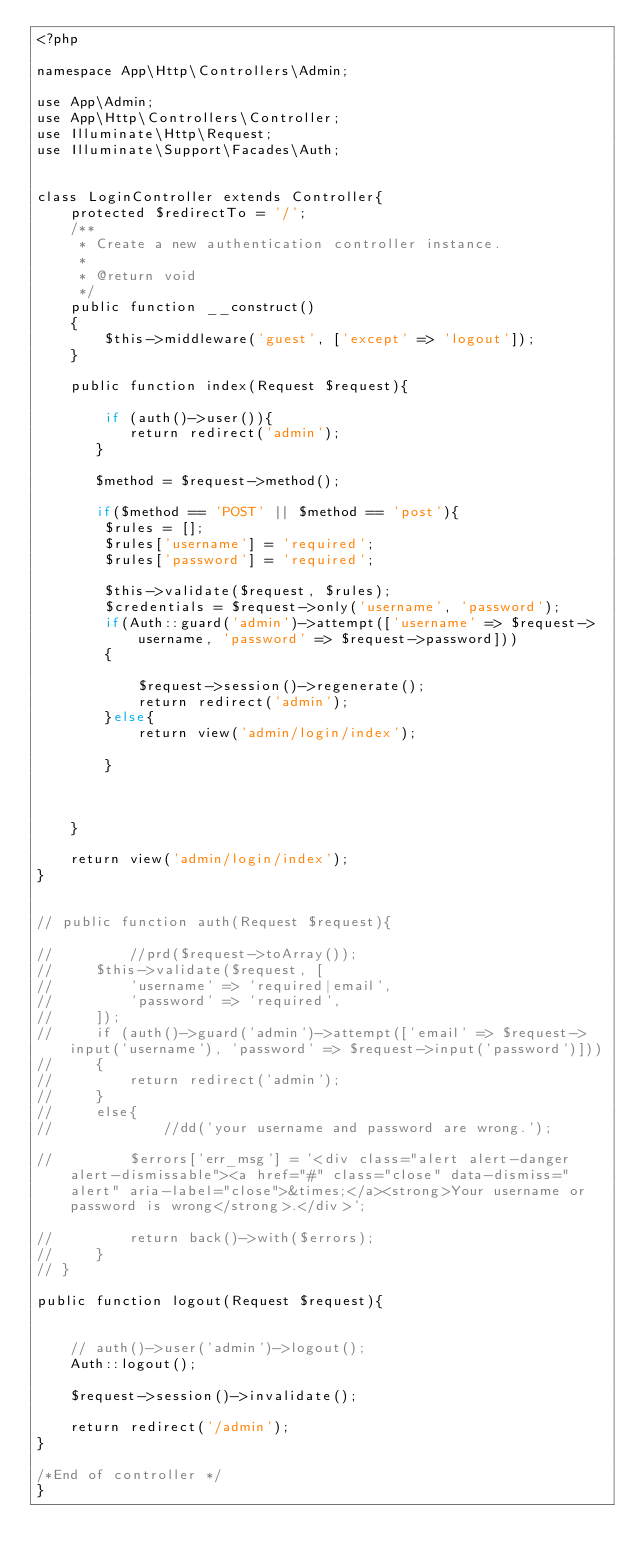Convert code to text. <code><loc_0><loc_0><loc_500><loc_500><_PHP_><?php

namespace App\Http\Controllers\Admin;

use App\Admin;
use App\Http\Controllers\Controller;
use Illuminate\Http\Request;
use Illuminate\Support\Facades\Auth;


class LoginController extends Controller{
    protected $redirectTo = '/';
    /**
     * Create a new authentication controller instance.
     *
     * @return void
     */
    public function __construct()
    {
        $this->middleware('guest', ['except' => 'logout']);
    }

    public function index(Request $request){

        if (auth()->user()){
           return redirect('admin');
       }

       $method = $request->method();

       if($method == 'POST' || $method == 'post'){
        $rules = [];
        $rules['username'] = 'required';
        $rules['password'] = 'required';

        $this->validate($request, $rules);
        $credentials = $request->only('username', 'password');
        if(Auth::guard('admin')->attempt(['username' => $request->username, 'password' => $request->password]))
        {
            
            $request->session()->regenerate();
            return redirect('admin');
        }else{
            return view('admin/login/index');
           
        }



    }

    return view('admin/login/index');
}


// public function auth(Request $request){

//         //prd($request->toArray());
//     $this->validate($request, [
//         'username' => 'required|email',
//         'password' => 'required',
//     ]);
//     if (auth()->guard('admin')->attempt(['email' => $request->input('username'), 'password' => $request->input('password')]))
//     {
//         return redirect('admin');
//     }
//     else{
//             //dd('your username and password are wrong.');

//         $errors['err_msg'] = '<div class="alert alert-danger alert-dismissable"><a href="#" class="close" data-dismiss="alert" aria-label="close">&times;</a><strong>Your username or password is wrong</strong>.</div>';

//         return back()->with($errors);
//     }
// }

public function logout(Request $request){


    // auth()->user('admin')->logout();
    Auth::logout();

    $request->session()->invalidate();

    return redirect('/admin');
}

/*End of controller */
}</code> 